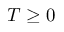Convert formula to latex. <formula><loc_0><loc_0><loc_500><loc_500>T \geq 0</formula> 